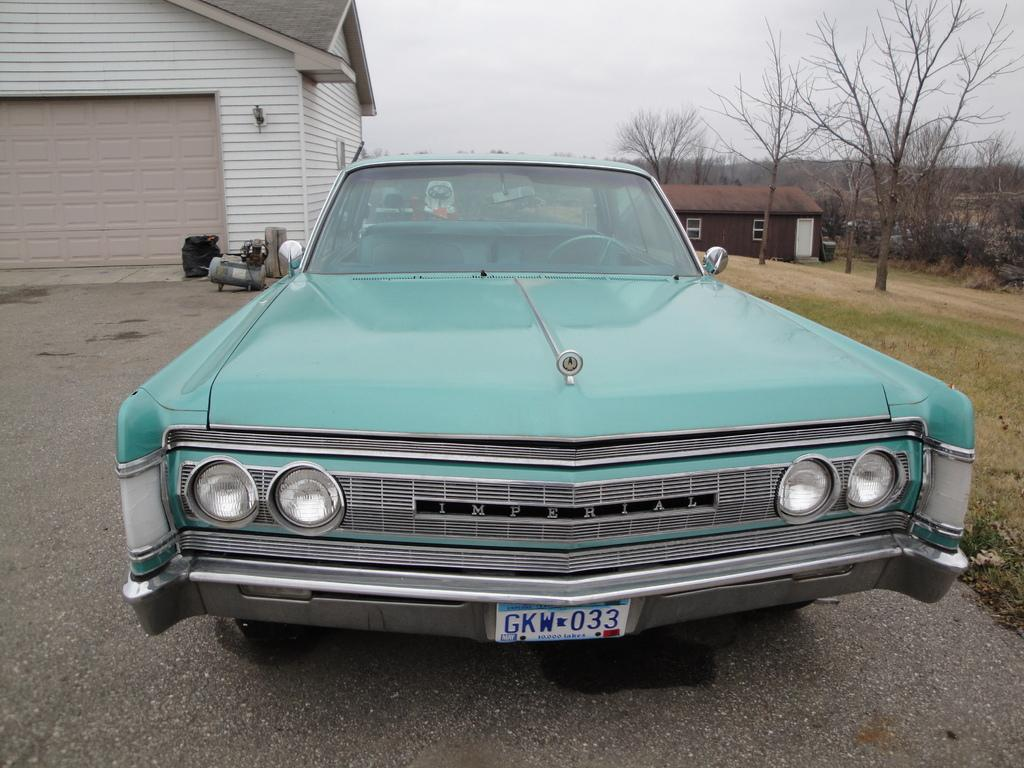What is located on the ground in the image? There is a car on the ground in the image. What type of structures can be seen in the image? There are houses with windows in the image. What type of vegetation is present in the image? There are trees in the image. What is visible in the background of the image? The sky is visible in the background of the image. Can you tell me what type of watch is being worn by the airplane in the image? There is no airplane or watch present in the image. 